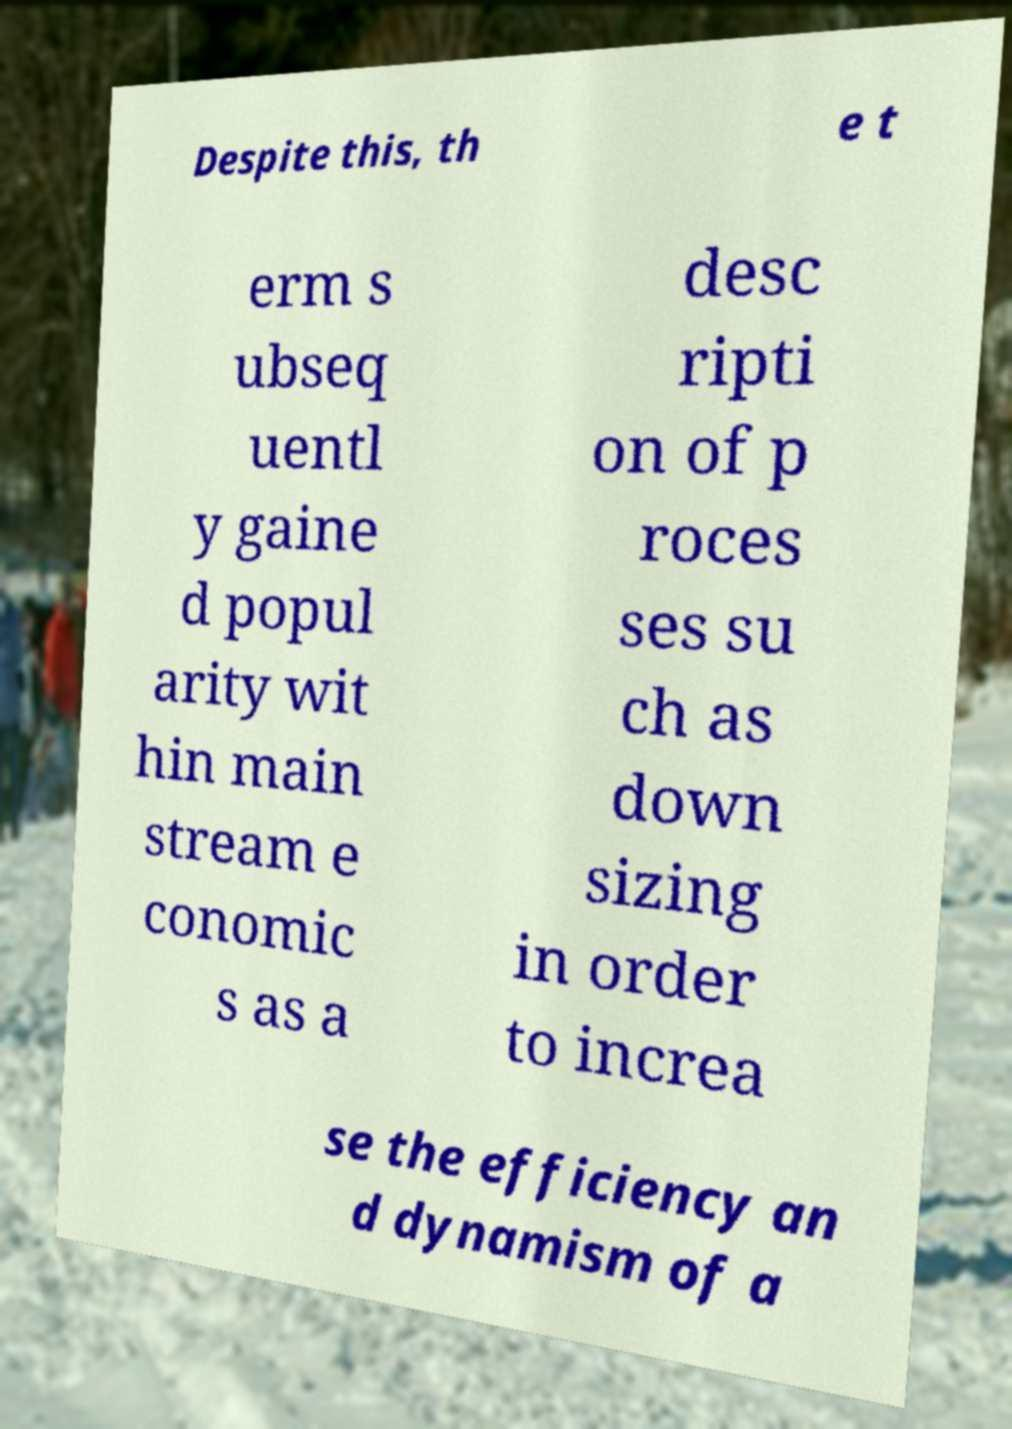Please read and relay the text visible in this image. What does it say? Despite this, th e t erm s ubseq uentl y gaine d popul arity wit hin main stream e conomic s as a desc ripti on of p roces ses su ch as down sizing in order to increa se the efficiency an d dynamism of a 